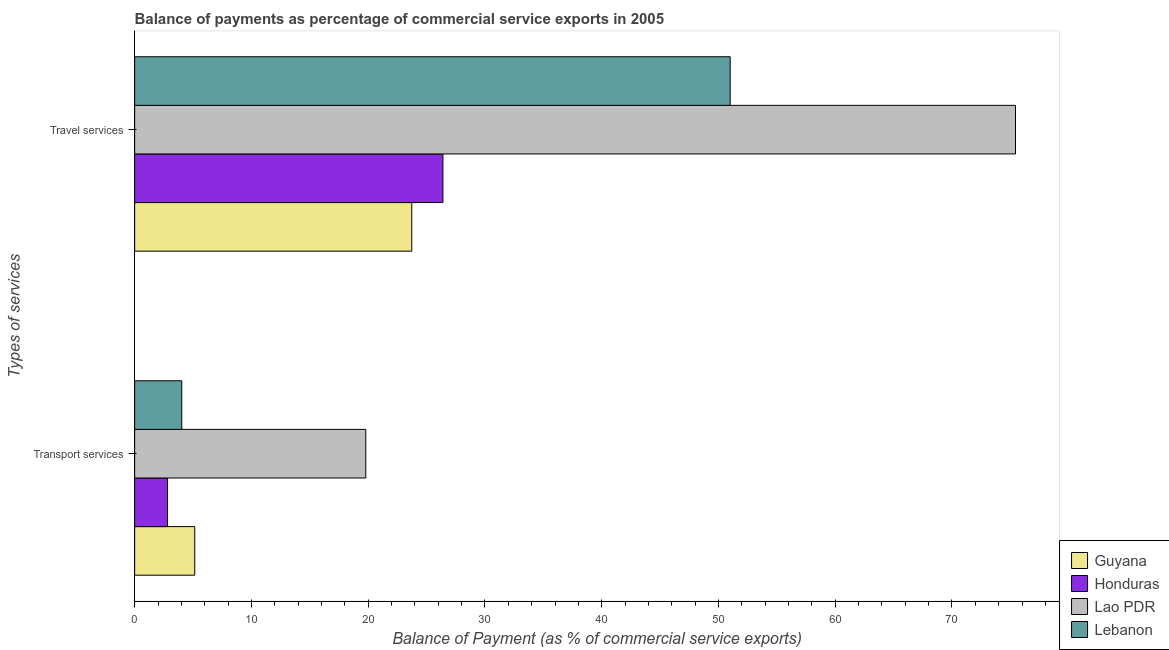Are the number of bars on each tick of the Y-axis equal?
Your answer should be compact. Yes. How many bars are there on the 1st tick from the top?
Keep it short and to the point. 4. What is the label of the 2nd group of bars from the top?
Provide a succinct answer. Transport services. What is the balance of payments of transport services in Guyana?
Provide a succinct answer. 5.15. Across all countries, what is the maximum balance of payments of transport services?
Your answer should be compact. 19.8. Across all countries, what is the minimum balance of payments of transport services?
Your answer should be compact. 2.81. In which country was the balance of payments of transport services maximum?
Offer a very short reply. Lao PDR. In which country was the balance of payments of travel services minimum?
Offer a very short reply. Guyana. What is the total balance of payments of travel services in the graph?
Make the answer very short. 176.58. What is the difference between the balance of payments of travel services in Lao PDR and that in Guyana?
Provide a succinct answer. 51.71. What is the difference between the balance of payments of transport services in Guyana and the balance of payments of travel services in Lebanon?
Ensure brevity in your answer.  -45.86. What is the average balance of payments of travel services per country?
Give a very brief answer. 44.15. What is the difference between the balance of payments of travel services and balance of payments of transport services in Lao PDR?
Keep it short and to the point. 55.64. In how many countries, is the balance of payments of travel services greater than 56 %?
Ensure brevity in your answer.  1. What is the ratio of the balance of payments of travel services in Lebanon to that in Guyana?
Your answer should be very brief. 2.15. Is the balance of payments of transport services in Lebanon less than that in Guyana?
Give a very brief answer. Yes. In how many countries, is the balance of payments of transport services greater than the average balance of payments of transport services taken over all countries?
Provide a succinct answer. 1. What does the 3rd bar from the top in Transport services represents?
Offer a terse response. Honduras. What does the 4th bar from the bottom in Travel services represents?
Your response must be concise. Lebanon. How many bars are there?
Offer a very short reply. 8. Are the values on the major ticks of X-axis written in scientific E-notation?
Offer a very short reply. No. Where does the legend appear in the graph?
Your answer should be very brief. Bottom right. How many legend labels are there?
Provide a succinct answer. 4. What is the title of the graph?
Provide a short and direct response. Balance of payments as percentage of commercial service exports in 2005. What is the label or title of the X-axis?
Provide a succinct answer. Balance of Payment (as % of commercial service exports). What is the label or title of the Y-axis?
Offer a very short reply. Types of services. What is the Balance of Payment (as % of commercial service exports) in Guyana in Transport services?
Offer a very short reply. 5.15. What is the Balance of Payment (as % of commercial service exports) in Honduras in Transport services?
Your answer should be very brief. 2.81. What is the Balance of Payment (as % of commercial service exports) of Lao PDR in Transport services?
Offer a very short reply. 19.8. What is the Balance of Payment (as % of commercial service exports) in Lebanon in Transport services?
Your answer should be very brief. 4.04. What is the Balance of Payment (as % of commercial service exports) in Guyana in Travel services?
Give a very brief answer. 23.73. What is the Balance of Payment (as % of commercial service exports) of Honduras in Travel services?
Ensure brevity in your answer.  26.4. What is the Balance of Payment (as % of commercial service exports) in Lao PDR in Travel services?
Make the answer very short. 75.44. What is the Balance of Payment (as % of commercial service exports) of Lebanon in Travel services?
Give a very brief answer. 51. Across all Types of services, what is the maximum Balance of Payment (as % of commercial service exports) of Guyana?
Offer a very short reply. 23.73. Across all Types of services, what is the maximum Balance of Payment (as % of commercial service exports) of Honduras?
Ensure brevity in your answer.  26.4. Across all Types of services, what is the maximum Balance of Payment (as % of commercial service exports) of Lao PDR?
Offer a very short reply. 75.44. Across all Types of services, what is the maximum Balance of Payment (as % of commercial service exports) of Lebanon?
Your response must be concise. 51. Across all Types of services, what is the minimum Balance of Payment (as % of commercial service exports) in Guyana?
Make the answer very short. 5.15. Across all Types of services, what is the minimum Balance of Payment (as % of commercial service exports) in Honduras?
Your answer should be compact. 2.81. Across all Types of services, what is the minimum Balance of Payment (as % of commercial service exports) of Lao PDR?
Provide a succinct answer. 19.8. Across all Types of services, what is the minimum Balance of Payment (as % of commercial service exports) of Lebanon?
Offer a terse response. 4.04. What is the total Balance of Payment (as % of commercial service exports) in Guyana in the graph?
Make the answer very short. 28.88. What is the total Balance of Payment (as % of commercial service exports) in Honduras in the graph?
Offer a terse response. 29.21. What is the total Balance of Payment (as % of commercial service exports) in Lao PDR in the graph?
Make the answer very short. 95.23. What is the total Balance of Payment (as % of commercial service exports) of Lebanon in the graph?
Make the answer very short. 55.04. What is the difference between the Balance of Payment (as % of commercial service exports) in Guyana in Transport services and that in Travel services?
Provide a short and direct response. -18.59. What is the difference between the Balance of Payment (as % of commercial service exports) in Honduras in Transport services and that in Travel services?
Your response must be concise. -23.59. What is the difference between the Balance of Payment (as % of commercial service exports) of Lao PDR in Transport services and that in Travel services?
Offer a very short reply. -55.64. What is the difference between the Balance of Payment (as % of commercial service exports) in Lebanon in Transport services and that in Travel services?
Offer a very short reply. -46.97. What is the difference between the Balance of Payment (as % of commercial service exports) of Guyana in Transport services and the Balance of Payment (as % of commercial service exports) of Honduras in Travel services?
Give a very brief answer. -21.26. What is the difference between the Balance of Payment (as % of commercial service exports) of Guyana in Transport services and the Balance of Payment (as % of commercial service exports) of Lao PDR in Travel services?
Provide a succinct answer. -70.29. What is the difference between the Balance of Payment (as % of commercial service exports) of Guyana in Transport services and the Balance of Payment (as % of commercial service exports) of Lebanon in Travel services?
Offer a very short reply. -45.86. What is the difference between the Balance of Payment (as % of commercial service exports) in Honduras in Transport services and the Balance of Payment (as % of commercial service exports) in Lao PDR in Travel services?
Offer a terse response. -72.63. What is the difference between the Balance of Payment (as % of commercial service exports) of Honduras in Transport services and the Balance of Payment (as % of commercial service exports) of Lebanon in Travel services?
Provide a short and direct response. -48.2. What is the difference between the Balance of Payment (as % of commercial service exports) in Lao PDR in Transport services and the Balance of Payment (as % of commercial service exports) in Lebanon in Travel services?
Provide a succinct answer. -31.21. What is the average Balance of Payment (as % of commercial service exports) of Guyana per Types of services?
Offer a terse response. 14.44. What is the average Balance of Payment (as % of commercial service exports) in Honduras per Types of services?
Give a very brief answer. 14.61. What is the average Balance of Payment (as % of commercial service exports) of Lao PDR per Types of services?
Offer a very short reply. 47.62. What is the average Balance of Payment (as % of commercial service exports) in Lebanon per Types of services?
Your response must be concise. 27.52. What is the difference between the Balance of Payment (as % of commercial service exports) of Guyana and Balance of Payment (as % of commercial service exports) of Honduras in Transport services?
Provide a succinct answer. 2.34. What is the difference between the Balance of Payment (as % of commercial service exports) in Guyana and Balance of Payment (as % of commercial service exports) in Lao PDR in Transport services?
Ensure brevity in your answer.  -14.65. What is the difference between the Balance of Payment (as % of commercial service exports) in Guyana and Balance of Payment (as % of commercial service exports) in Lebanon in Transport services?
Provide a short and direct response. 1.11. What is the difference between the Balance of Payment (as % of commercial service exports) in Honduras and Balance of Payment (as % of commercial service exports) in Lao PDR in Transport services?
Your answer should be compact. -16.99. What is the difference between the Balance of Payment (as % of commercial service exports) in Honduras and Balance of Payment (as % of commercial service exports) in Lebanon in Transport services?
Provide a short and direct response. -1.23. What is the difference between the Balance of Payment (as % of commercial service exports) in Lao PDR and Balance of Payment (as % of commercial service exports) in Lebanon in Transport services?
Make the answer very short. 15.76. What is the difference between the Balance of Payment (as % of commercial service exports) in Guyana and Balance of Payment (as % of commercial service exports) in Honduras in Travel services?
Ensure brevity in your answer.  -2.67. What is the difference between the Balance of Payment (as % of commercial service exports) in Guyana and Balance of Payment (as % of commercial service exports) in Lao PDR in Travel services?
Ensure brevity in your answer.  -51.71. What is the difference between the Balance of Payment (as % of commercial service exports) in Guyana and Balance of Payment (as % of commercial service exports) in Lebanon in Travel services?
Keep it short and to the point. -27.27. What is the difference between the Balance of Payment (as % of commercial service exports) of Honduras and Balance of Payment (as % of commercial service exports) of Lao PDR in Travel services?
Provide a short and direct response. -49.04. What is the difference between the Balance of Payment (as % of commercial service exports) in Honduras and Balance of Payment (as % of commercial service exports) in Lebanon in Travel services?
Offer a very short reply. -24.6. What is the difference between the Balance of Payment (as % of commercial service exports) of Lao PDR and Balance of Payment (as % of commercial service exports) of Lebanon in Travel services?
Your answer should be very brief. 24.43. What is the ratio of the Balance of Payment (as % of commercial service exports) in Guyana in Transport services to that in Travel services?
Your answer should be compact. 0.22. What is the ratio of the Balance of Payment (as % of commercial service exports) of Honduras in Transport services to that in Travel services?
Your response must be concise. 0.11. What is the ratio of the Balance of Payment (as % of commercial service exports) of Lao PDR in Transport services to that in Travel services?
Ensure brevity in your answer.  0.26. What is the ratio of the Balance of Payment (as % of commercial service exports) of Lebanon in Transport services to that in Travel services?
Provide a succinct answer. 0.08. What is the difference between the highest and the second highest Balance of Payment (as % of commercial service exports) in Guyana?
Offer a very short reply. 18.59. What is the difference between the highest and the second highest Balance of Payment (as % of commercial service exports) in Honduras?
Provide a succinct answer. 23.59. What is the difference between the highest and the second highest Balance of Payment (as % of commercial service exports) in Lao PDR?
Provide a short and direct response. 55.64. What is the difference between the highest and the second highest Balance of Payment (as % of commercial service exports) in Lebanon?
Give a very brief answer. 46.97. What is the difference between the highest and the lowest Balance of Payment (as % of commercial service exports) of Guyana?
Keep it short and to the point. 18.59. What is the difference between the highest and the lowest Balance of Payment (as % of commercial service exports) in Honduras?
Provide a succinct answer. 23.59. What is the difference between the highest and the lowest Balance of Payment (as % of commercial service exports) of Lao PDR?
Provide a short and direct response. 55.64. What is the difference between the highest and the lowest Balance of Payment (as % of commercial service exports) in Lebanon?
Your response must be concise. 46.97. 